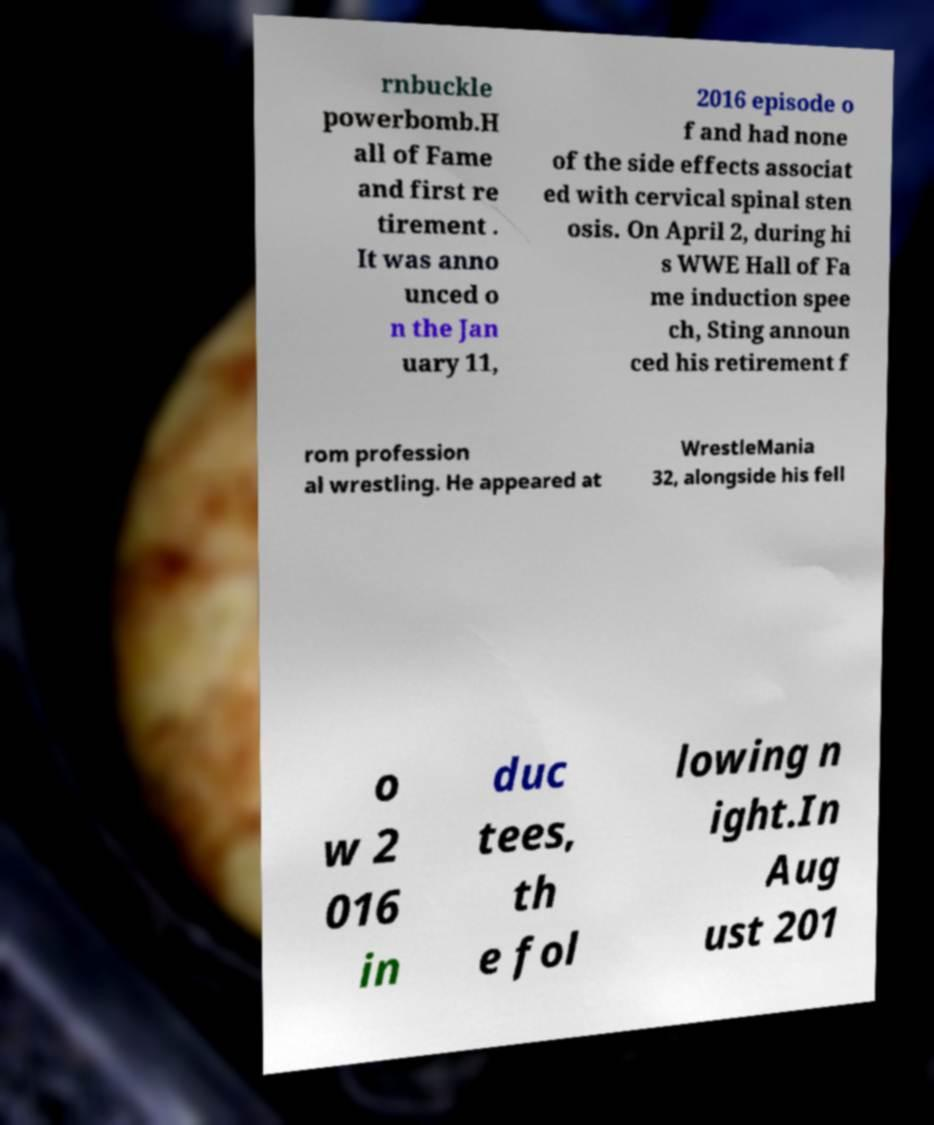There's text embedded in this image that I need extracted. Can you transcribe it verbatim? rnbuckle powerbomb.H all of Fame and first re tirement . It was anno unced o n the Jan uary 11, 2016 episode o f and had none of the side effects associat ed with cervical spinal sten osis. On April 2, during hi s WWE Hall of Fa me induction spee ch, Sting announ ced his retirement f rom profession al wrestling. He appeared at WrestleMania 32, alongside his fell o w 2 016 in duc tees, th e fol lowing n ight.In Aug ust 201 